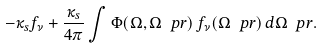Convert formula to latex. <formula><loc_0><loc_0><loc_500><loc_500>- \kappa _ { s } f _ { \nu } + \frac { \kappa _ { s } } { 4 \pi } \int \Phi ( { \Omega } , { \Omega \ p r } ) \, f _ { \nu } ( { \Omega \ p r } ) \, d \Omega \ p r .</formula> 